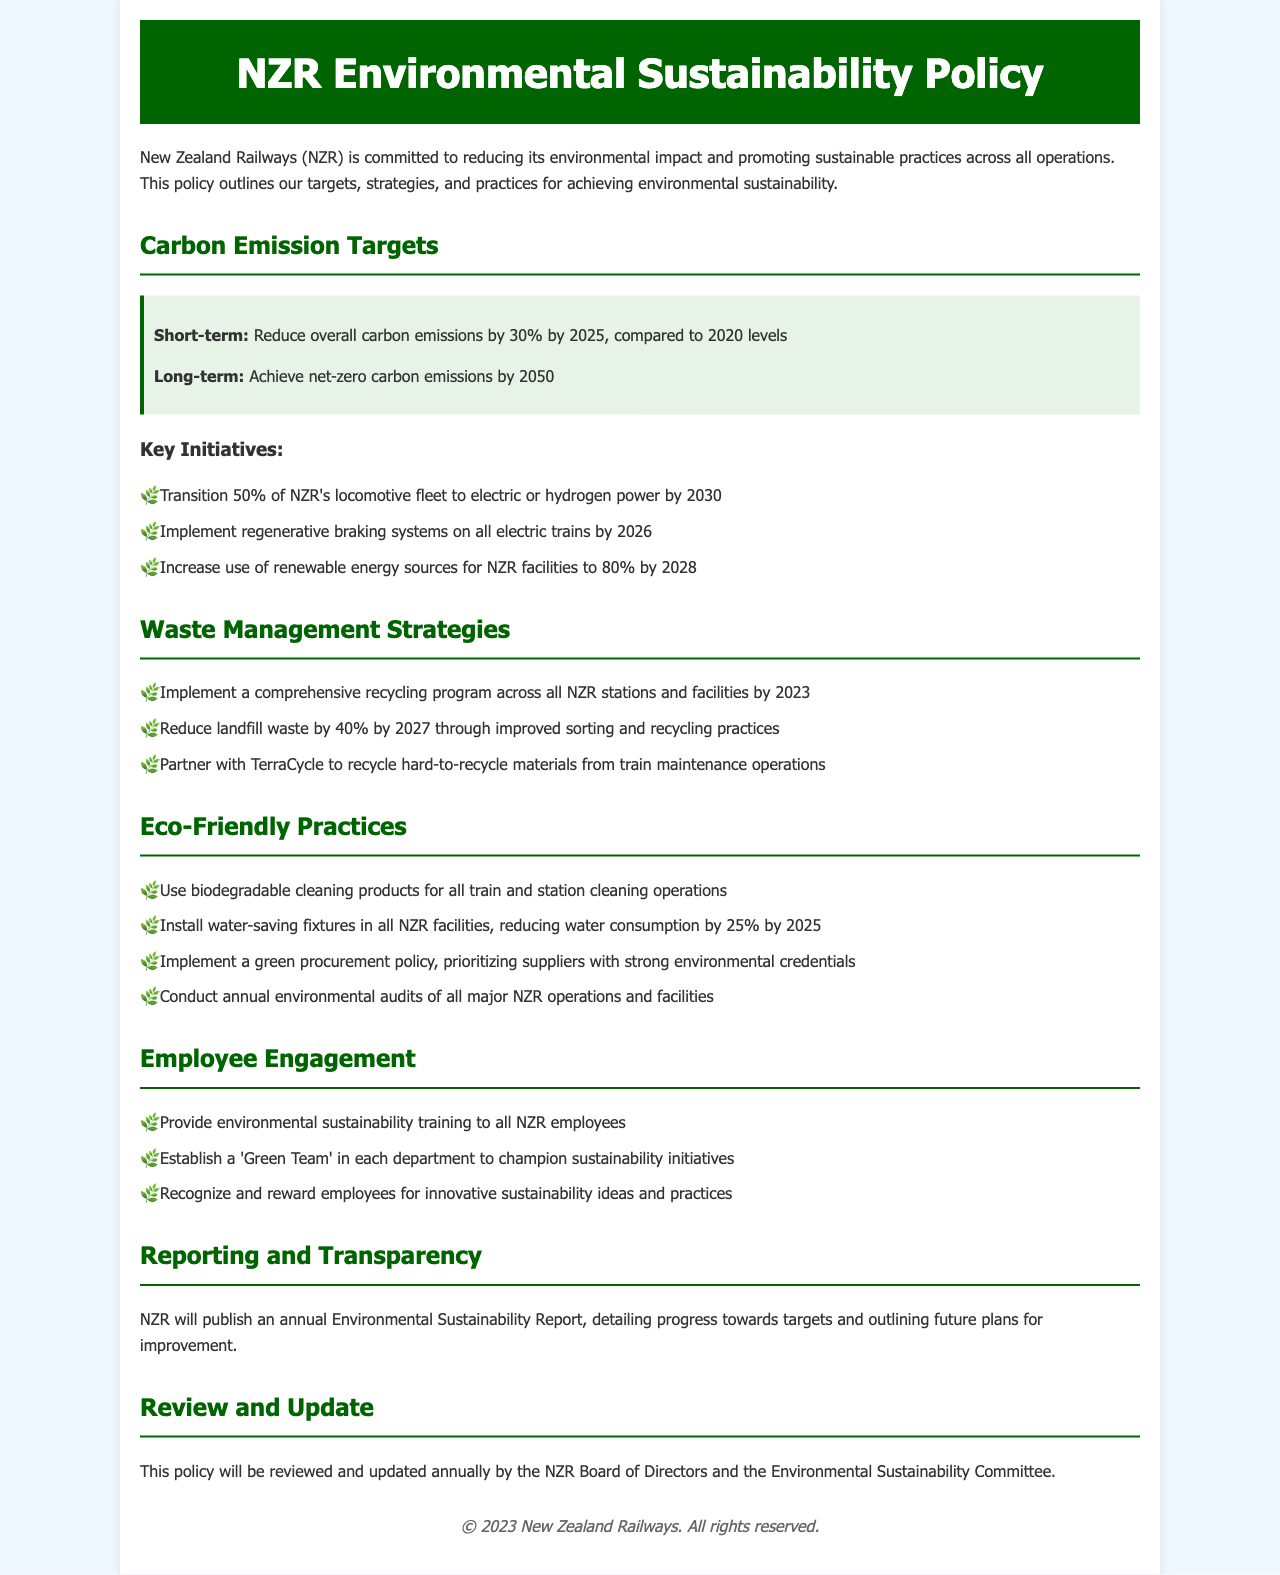what is the short-term carbon emission target? The short-term target is to reduce overall carbon emissions by 30% by 2025, compared to 2020 levels.
Answer: 30% what is the long-term carbon emission goal? The long-term goal is to achieve net-zero carbon emissions by 2050.
Answer: net-zero carbon emissions by 2050 when will the comprehensive recycling program be implemented? The comprehensive recycling program will be implemented across all NZR stations and facilities by 2023.
Answer: 2023 what is the waste reduction target by 2027? The waste reduction target is to reduce landfill waste by 40% by 2027.
Answer: 40% what energy source increase is aimed for NZR facilities by 2028? The aim is to increase use of renewable energy sources for NZR facilities to 80% by 2028.
Answer: 80% what product type is prioritized in the green procurement policy? The green procurement policy prioritizes suppliers with strong environmental credentials.
Answer: suppliers with strong environmental credentials how many employees will receive environmental sustainability training? All NZR employees will receive environmental sustainability training.
Answer: all NZR employees how frequently will the environmental sustainability policy be reviewed? The policy will be reviewed and updated annually.
Answer: annually what specific group will champion sustainability initiatives in departments? A 'Green Team' will be established in each department to champion sustainability initiatives.
Answer: 'Green Team' 